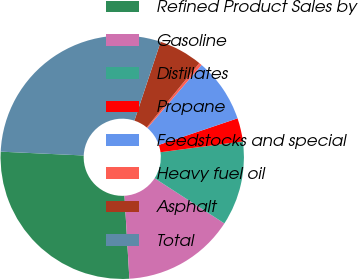<chart> <loc_0><loc_0><loc_500><loc_500><pie_chart><fcel>Refined Product Sales by<fcel>Gasoline<fcel>Distillates<fcel>Propane<fcel>Feedstocks and special<fcel>Heavy fuel oil<fcel>Asphalt<fcel>Total<nl><fcel>26.67%<fcel>14.92%<fcel>11.23%<fcel>3.1%<fcel>8.52%<fcel>0.38%<fcel>5.81%<fcel>29.38%<nl></chart> 